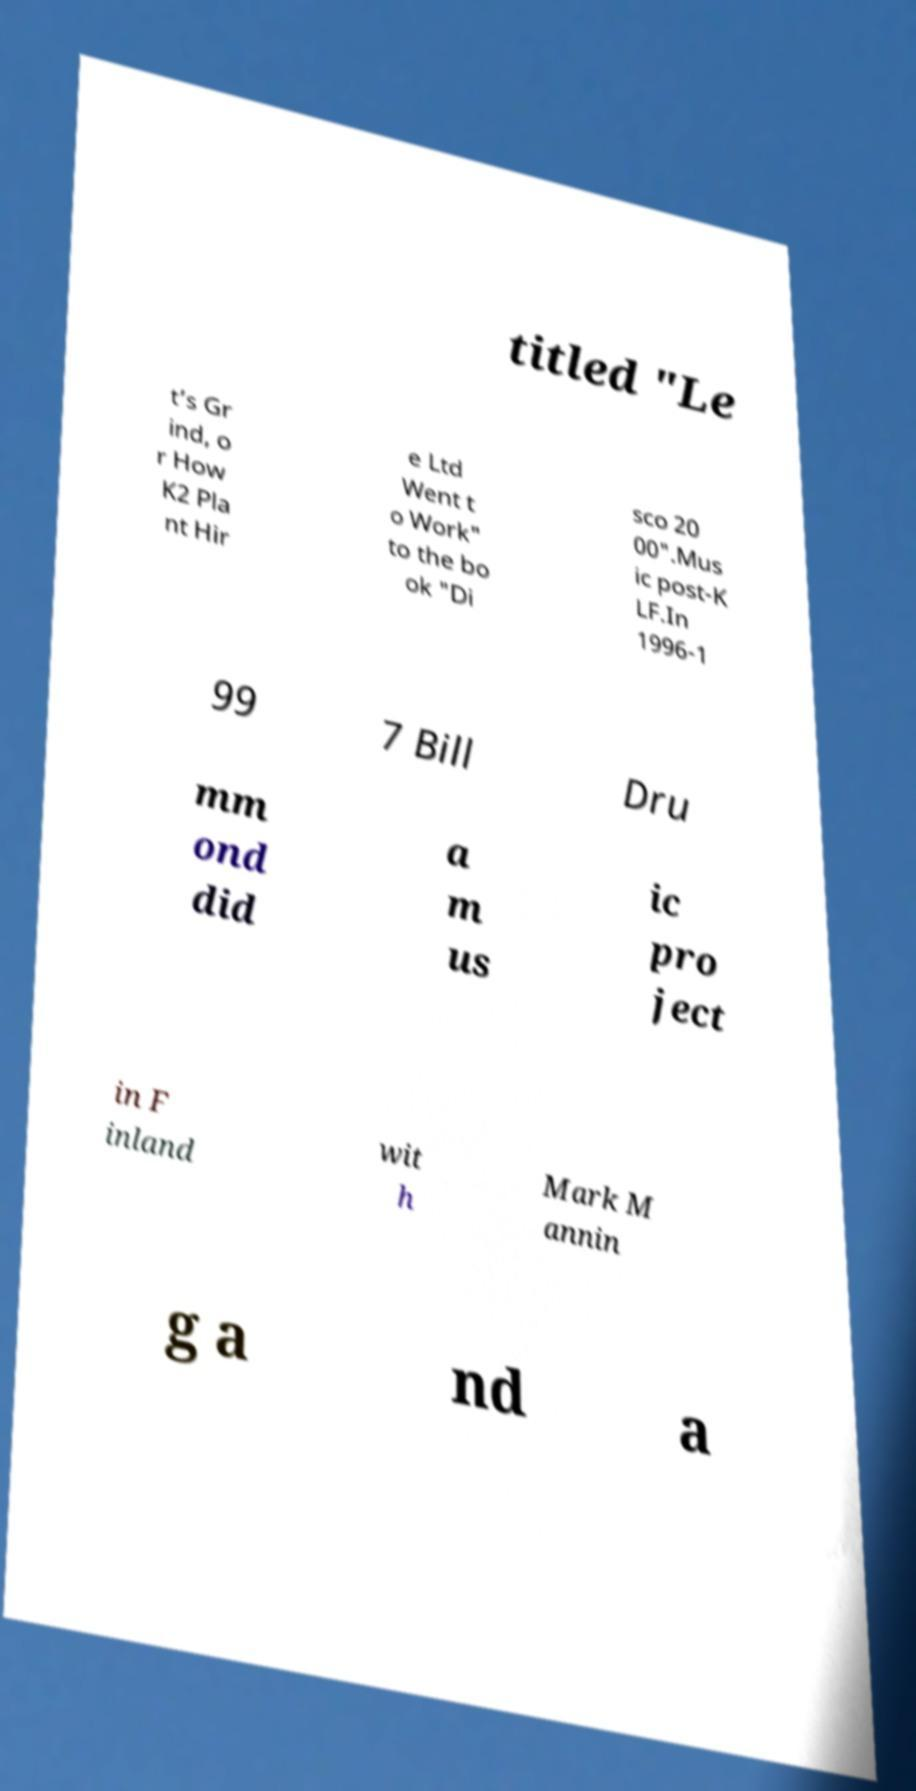Can you accurately transcribe the text from the provided image for me? titled "Le t’s Gr ind, o r How K2 Pla nt Hir e Ltd Went t o Work" to the bo ok "Di sco 20 00".Mus ic post-K LF.In 1996-1 99 7 Bill Dru mm ond did a m us ic pro ject in F inland wit h Mark M annin g a nd a 